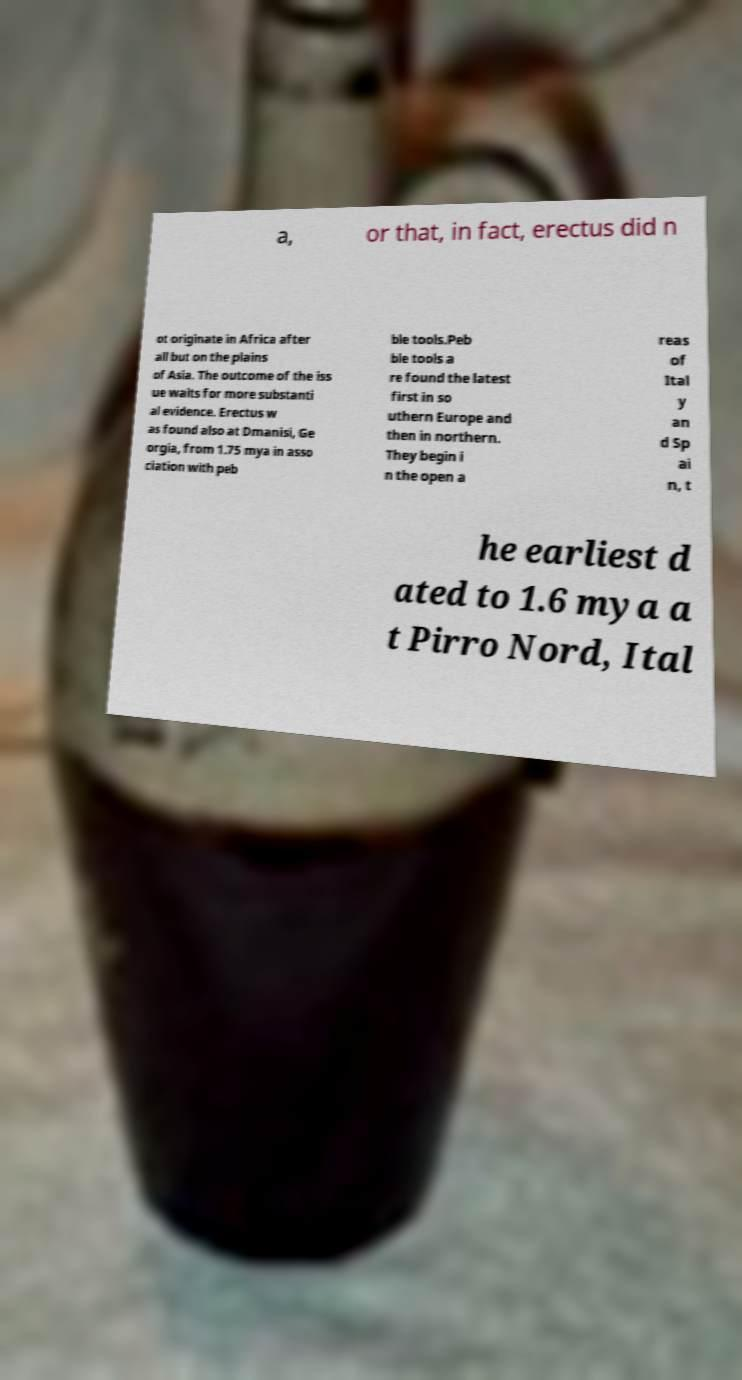What messages or text are displayed in this image? I need them in a readable, typed format. a, or that, in fact, erectus did n ot originate in Africa after all but on the plains of Asia. The outcome of the iss ue waits for more substanti al evidence. Erectus w as found also at Dmanisi, Ge orgia, from 1.75 mya in asso ciation with peb ble tools.Peb ble tools a re found the latest first in so uthern Europe and then in northern. They begin i n the open a reas of Ital y an d Sp ai n, t he earliest d ated to 1.6 mya a t Pirro Nord, Ital 